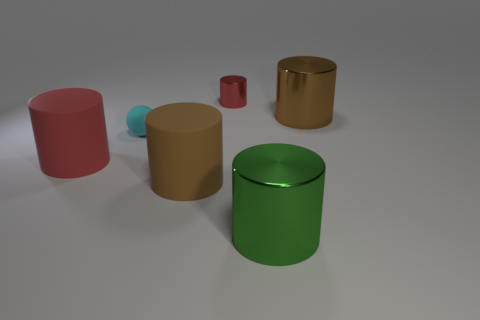Do the brown thing that is left of the tiny red cylinder and the big red cylinder have the same material?
Keep it short and to the point. Yes. What is the green cylinder made of?
Give a very brief answer. Metal. How big is the cyan ball that is behind the brown matte thing?
Keep it short and to the point. Small. Are there any other things that have the same color as the small sphere?
Your answer should be compact. No. There is a brown object that is behind the big brown cylinder that is in front of the cyan rubber thing; are there any matte cylinders that are to the right of it?
Your response must be concise. No. There is a big shiny thing to the right of the big green cylinder; is its color the same as the small cylinder?
Offer a very short reply. No. What number of cubes are either brown objects or small red things?
Keep it short and to the point. 0. The big brown matte thing on the left side of the big metal thing to the left of the big brown metal object is what shape?
Give a very brief answer. Cylinder. There is a red thing behind the large brown thing that is behind the large matte object on the left side of the cyan rubber sphere; what size is it?
Make the answer very short. Small. Do the cyan ball and the brown rubber thing have the same size?
Provide a short and direct response. No. 